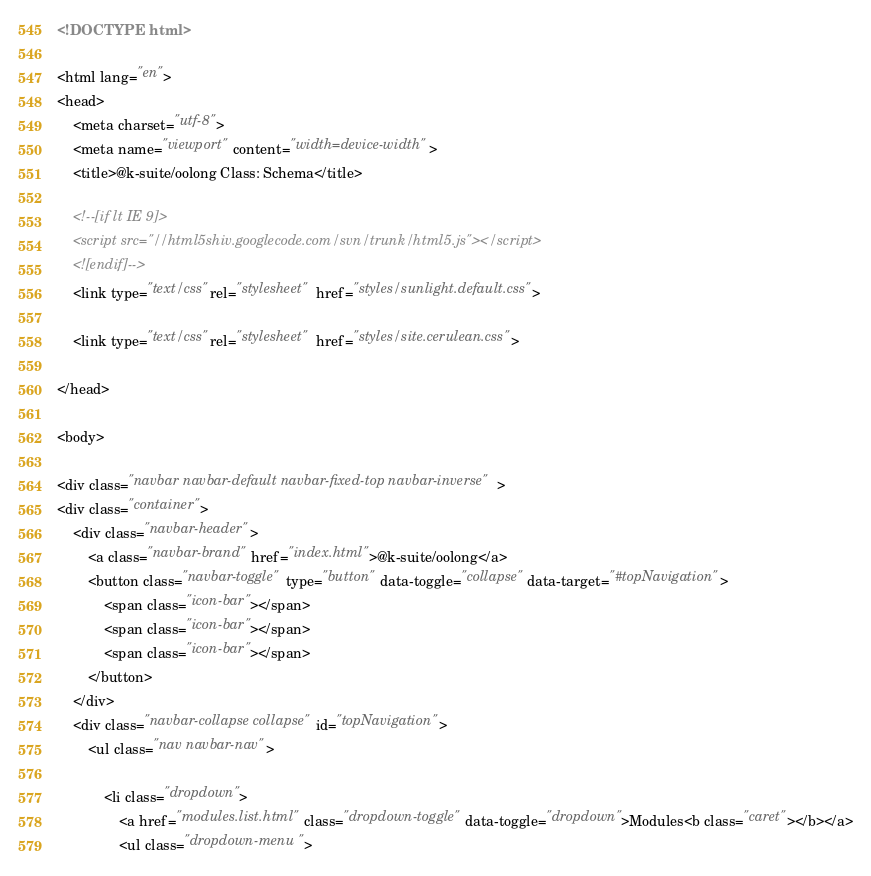Convert code to text. <code><loc_0><loc_0><loc_500><loc_500><_HTML_><!DOCTYPE html>

<html lang="en">
<head>
	<meta charset="utf-8">
	<meta name="viewport" content="width=device-width">
	<title>@k-suite/oolong Class: Schema</title>

	<!--[if lt IE 9]>
	<script src="//html5shiv.googlecode.com/svn/trunk/html5.js"></script>
	<![endif]-->
	<link type="text/css" rel="stylesheet" href="styles/sunlight.default.css">

	<link type="text/css" rel="stylesheet" href="styles/site.cerulean.css">

</head>

<body>

<div class="navbar navbar-default navbar-fixed-top navbar-inverse">
<div class="container">
	<div class="navbar-header">
		<a class="navbar-brand" href="index.html">@k-suite/oolong</a>
		<button class="navbar-toggle" type="button" data-toggle="collapse" data-target="#topNavigation">
			<span class="icon-bar"></span>
			<span class="icon-bar"></span>
			<span class="icon-bar"></span>
        </button>
	</div>
	<div class="navbar-collapse collapse" id="topNavigation">
		<ul class="nav navbar-nav">
			
			<li class="dropdown">
				<a href="modules.list.html" class="dropdown-toggle" data-toggle="dropdown">Modules<b class="caret"></b></a>
				<ul class="dropdown-menu "></code> 